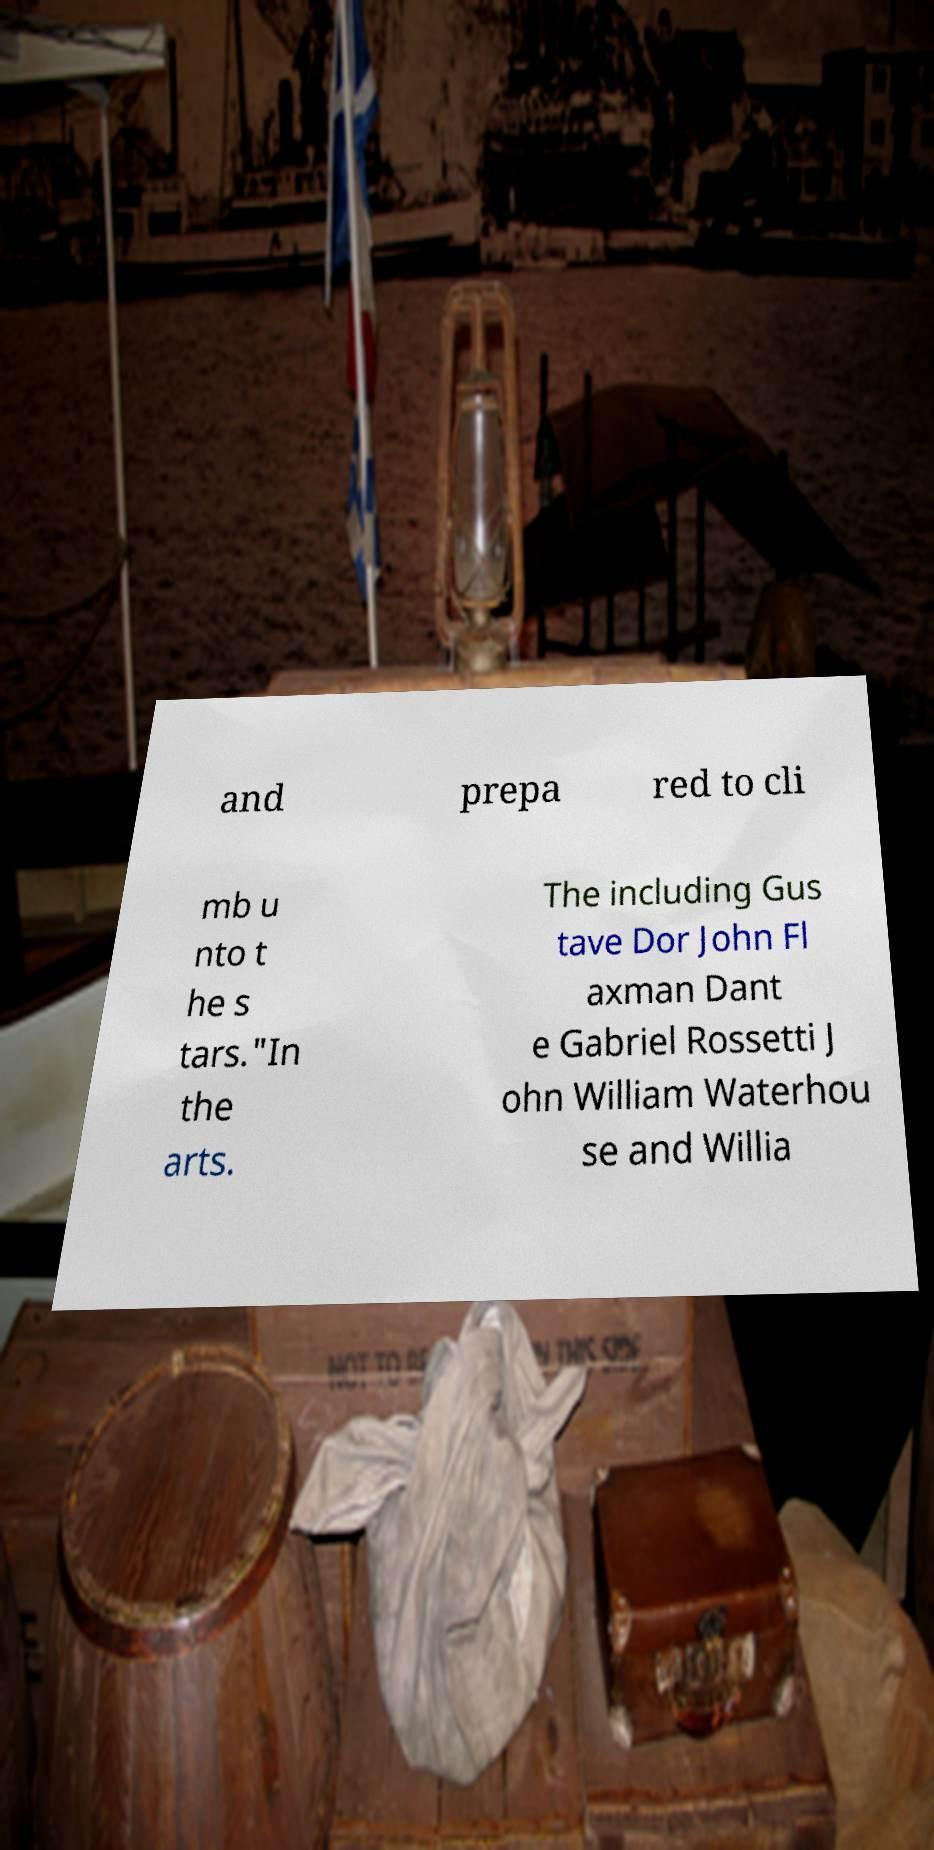I need the written content from this picture converted into text. Can you do that? and prepa red to cli mb u nto t he s tars."In the arts. The including Gus tave Dor John Fl axman Dant e Gabriel Rossetti J ohn William Waterhou se and Willia 